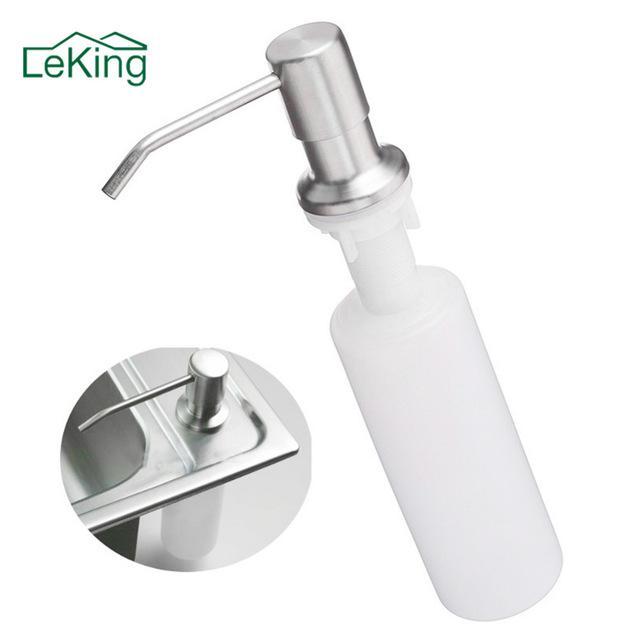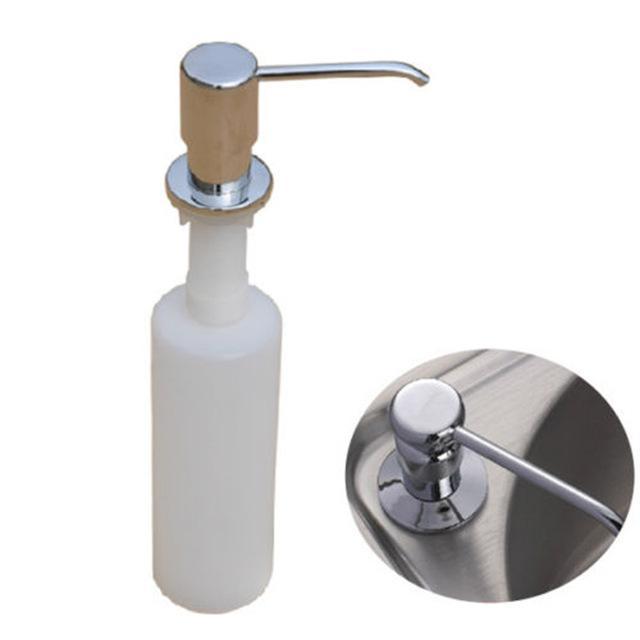The first image is the image on the left, the second image is the image on the right. Given the left and right images, does the statement "There is a circle-shaped inset image in one or more images." hold true? Answer yes or no. Yes. 